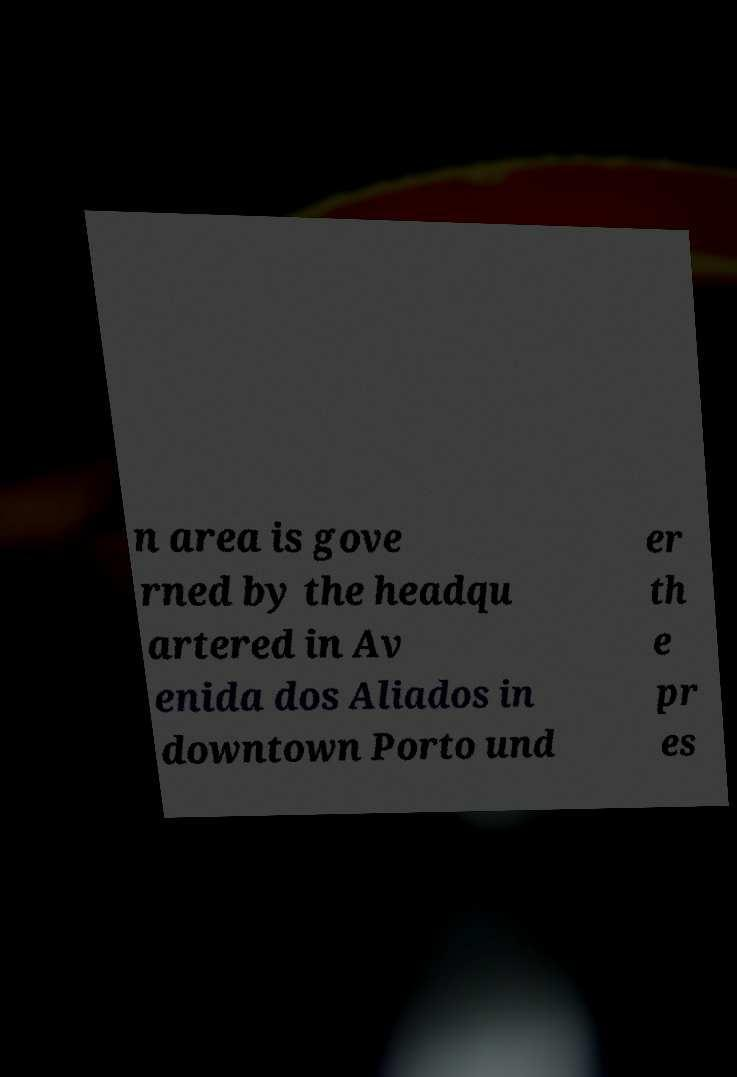What messages or text are displayed in this image? I need them in a readable, typed format. n area is gove rned by the headqu artered in Av enida dos Aliados in downtown Porto und er th e pr es 